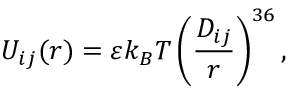<formula> <loc_0><loc_0><loc_500><loc_500>U _ { i j } ( r ) = \varepsilon k _ { B } T \left ( \frac { D _ { i j } } { r } \right ) ^ { 3 6 } ,</formula> 